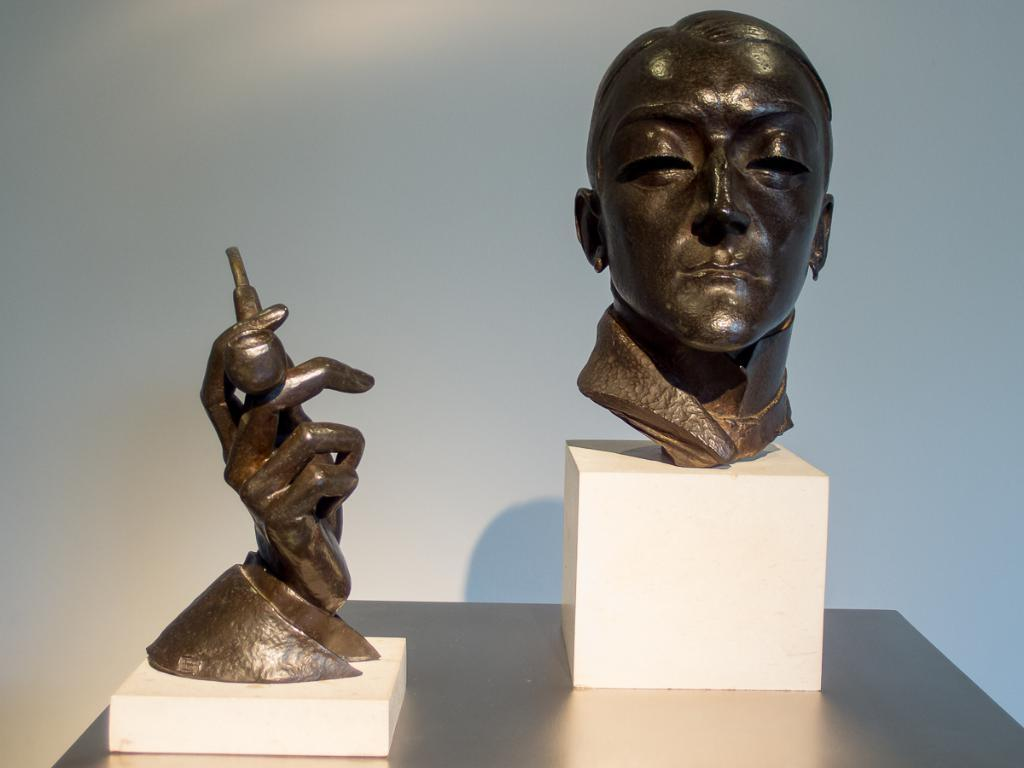What is the main subject in the center of the image? There are sculptures in the center of the image. How are the sculptures positioned? The sculptures are on boxes. What is located at the bottom of the image? There is a table at the bottom of the image. What can be seen in the background of the image? There is a wall in the background of the image. How many seeds are scattered on the table in the image? There is no mention of seeds in the image; the main subjects are the sculptures and their positioning on the boxes. 